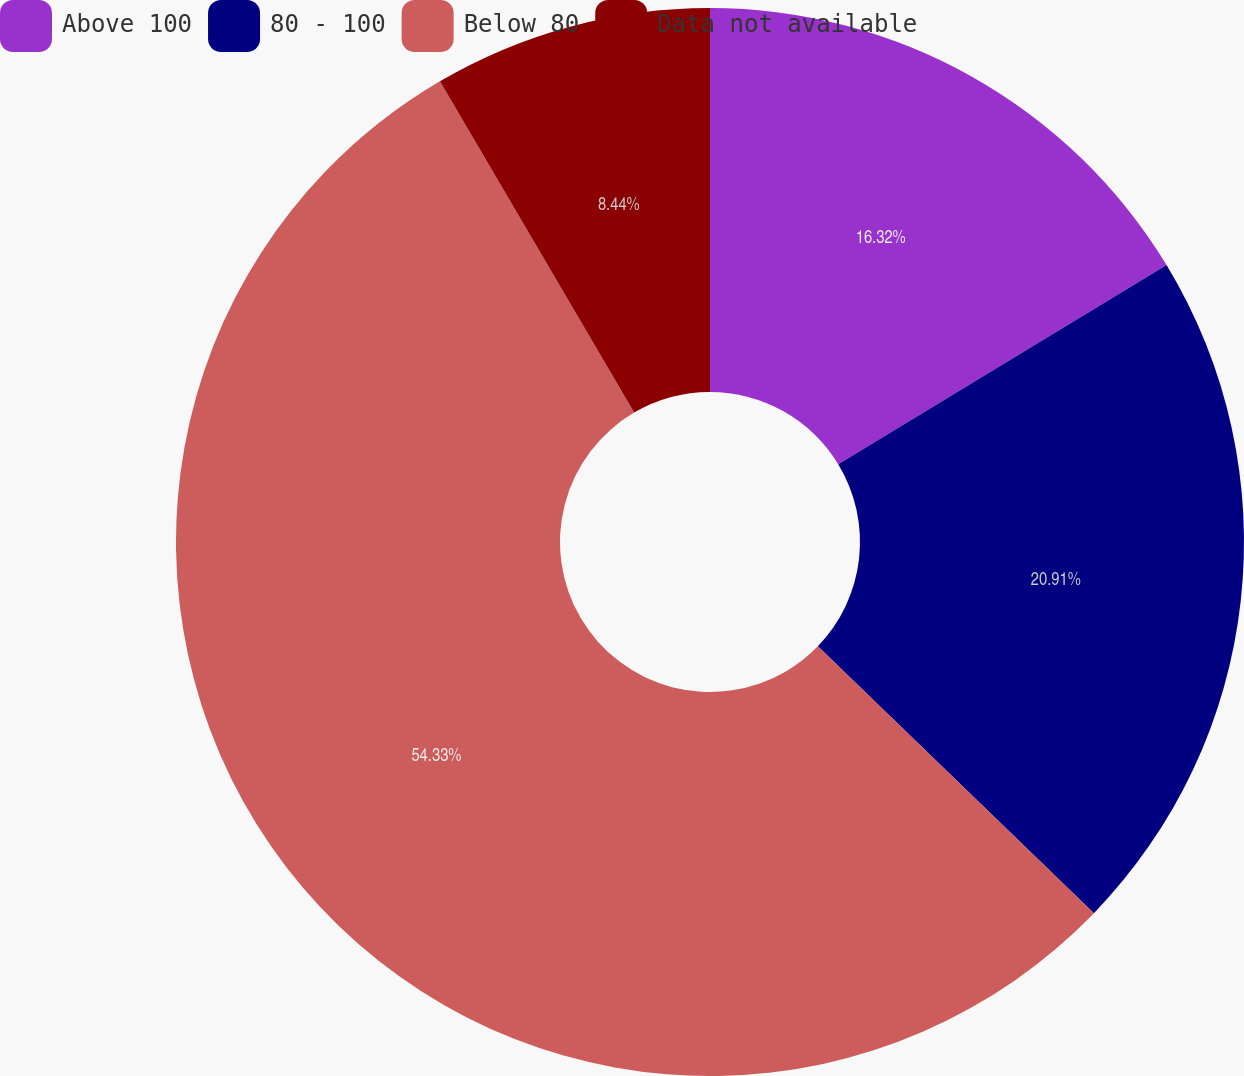Convert chart to OTSL. <chart><loc_0><loc_0><loc_500><loc_500><pie_chart><fcel>Above 100<fcel>80 - 100<fcel>Below 80<fcel>Data not available<nl><fcel>16.32%<fcel>20.91%<fcel>54.33%<fcel>8.44%<nl></chart> 